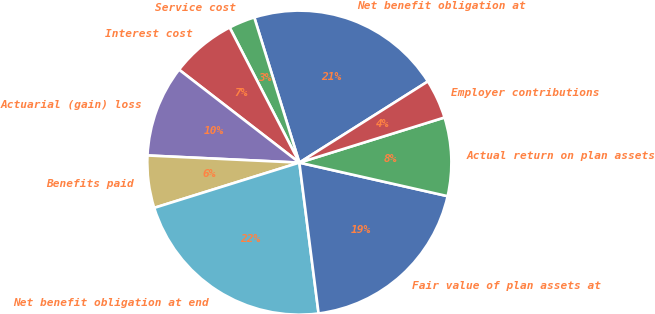Convert chart. <chart><loc_0><loc_0><loc_500><loc_500><pie_chart><fcel>Net benefit obligation at<fcel>Service cost<fcel>Interest cost<fcel>Actuarial (gain) loss<fcel>Benefits paid<fcel>Net benefit obligation at end<fcel>Fair value of plan assets at<fcel>Actual return on plan assets<fcel>Employer contributions<nl><fcel>20.82%<fcel>2.79%<fcel>6.95%<fcel>9.72%<fcel>5.56%<fcel>22.21%<fcel>19.44%<fcel>8.34%<fcel>4.17%<nl></chart> 